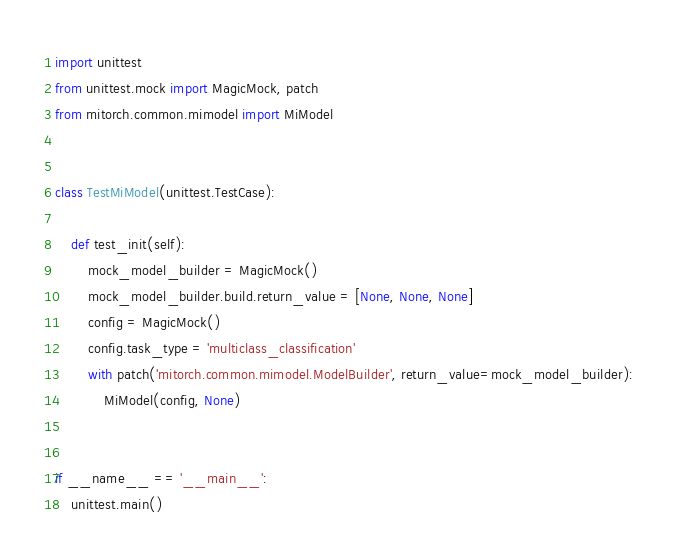<code> <loc_0><loc_0><loc_500><loc_500><_Python_>import unittest
from unittest.mock import MagicMock, patch
from mitorch.common.mimodel import MiModel


class TestMiModel(unittest.TestCase):

    def test_init(self):
        mock_model_builder = MagicMock()
        mock_model_builder.build.return_value = [None, None, None]
        config = MagicMock()
        config.task_type = 'multiclass_classification'
        with patch('mitorch.common.mimodel.ModelBuilder', return_value=mock_model_builder):
            MiModel(config, None)


if __name__ == '__main__':
    unittest.main()
</code> 